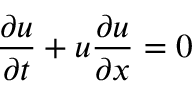Convert formula to latex. <formula><loc_0><loc_0><loc_500><loc_500>\frac { \partial u } { \partial t } + u \frac { \partial u } { \partial x } = 0</formula> 